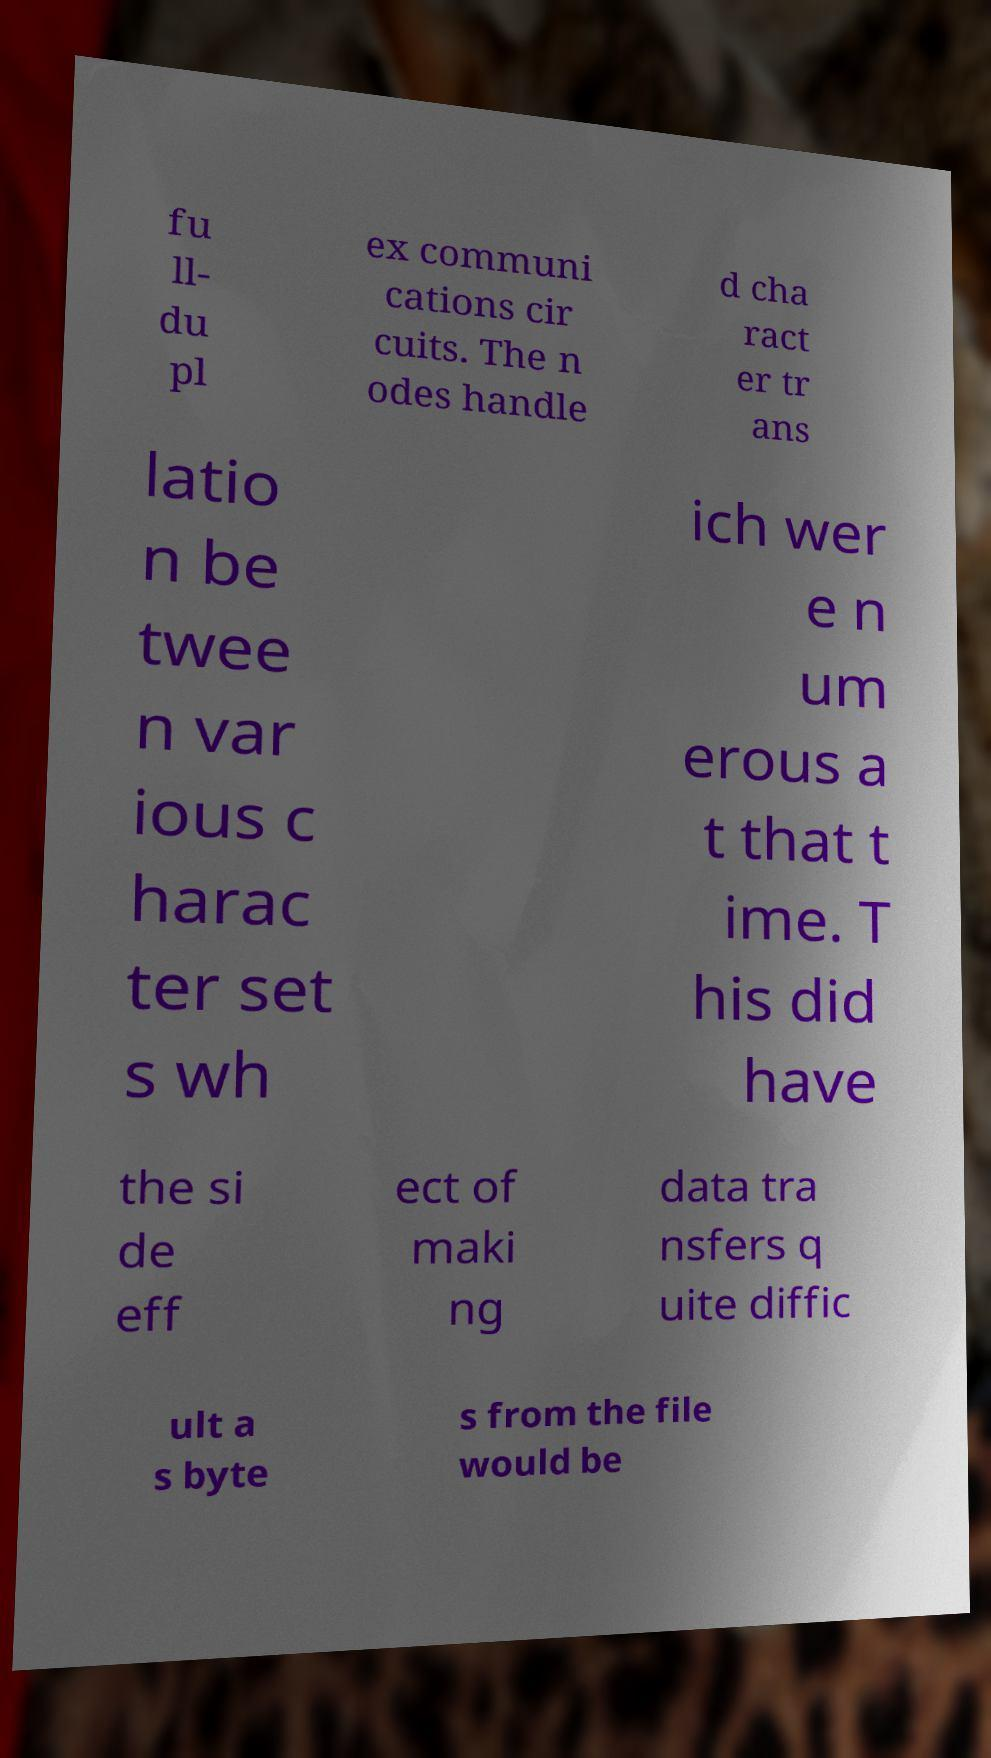There's text embedded in this image that I need extracted. Can you transcribe it verbatim? fu ll- du pl ex communi cations cir cuits. The n odes handle d cha ract er tr ans latio n be twee n var ious c harac ter set s wh ich wer e n um erous a t that t ime. T his did have the si de eff ect of maki ng data tra nsfers q uite diffic ult a s byte s from the file would be 